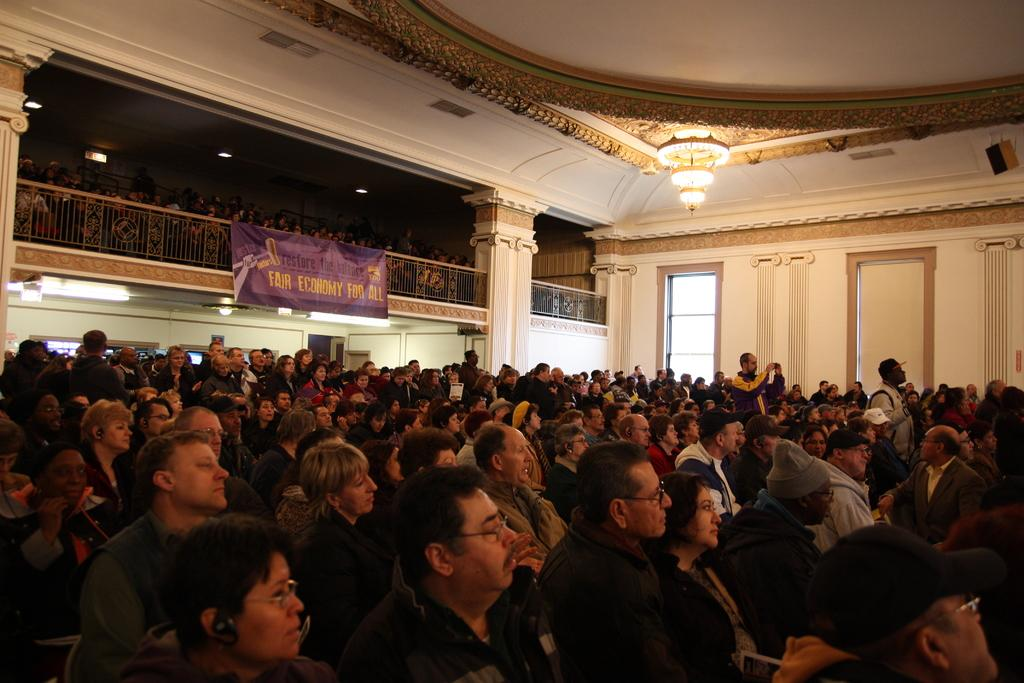How many people are in the image? There is a group of people in the image, but the exact number is not specified. What are the people in the image doing? Some people are seated, while others are standing. What is the large sign in the image called? There is a hoarding in the image. What can be seen illuminated in the image? There are lights visible in the image. What type of barrier is present in the image? There is a fence in the image. Can you see a receipt on the ground in the image? There is no mention of a receipt in the image, so it cannot be confirmed or denied. What type of insect can be seen flying near the lights in the image? There is no mention of any insects in the image, so it cannot be confirmed or denied. 